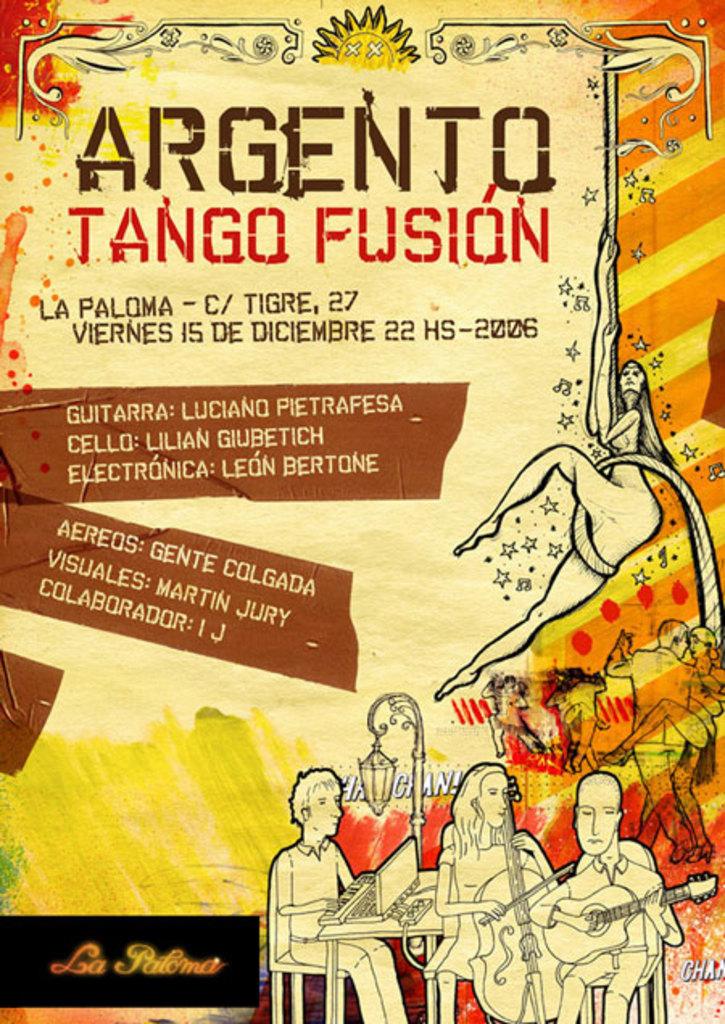What kind of tango is this?
Keep it short and to the point. Argento tango fusion. What is the book called?
Provide a short and direct response. Argento tango fusion. 